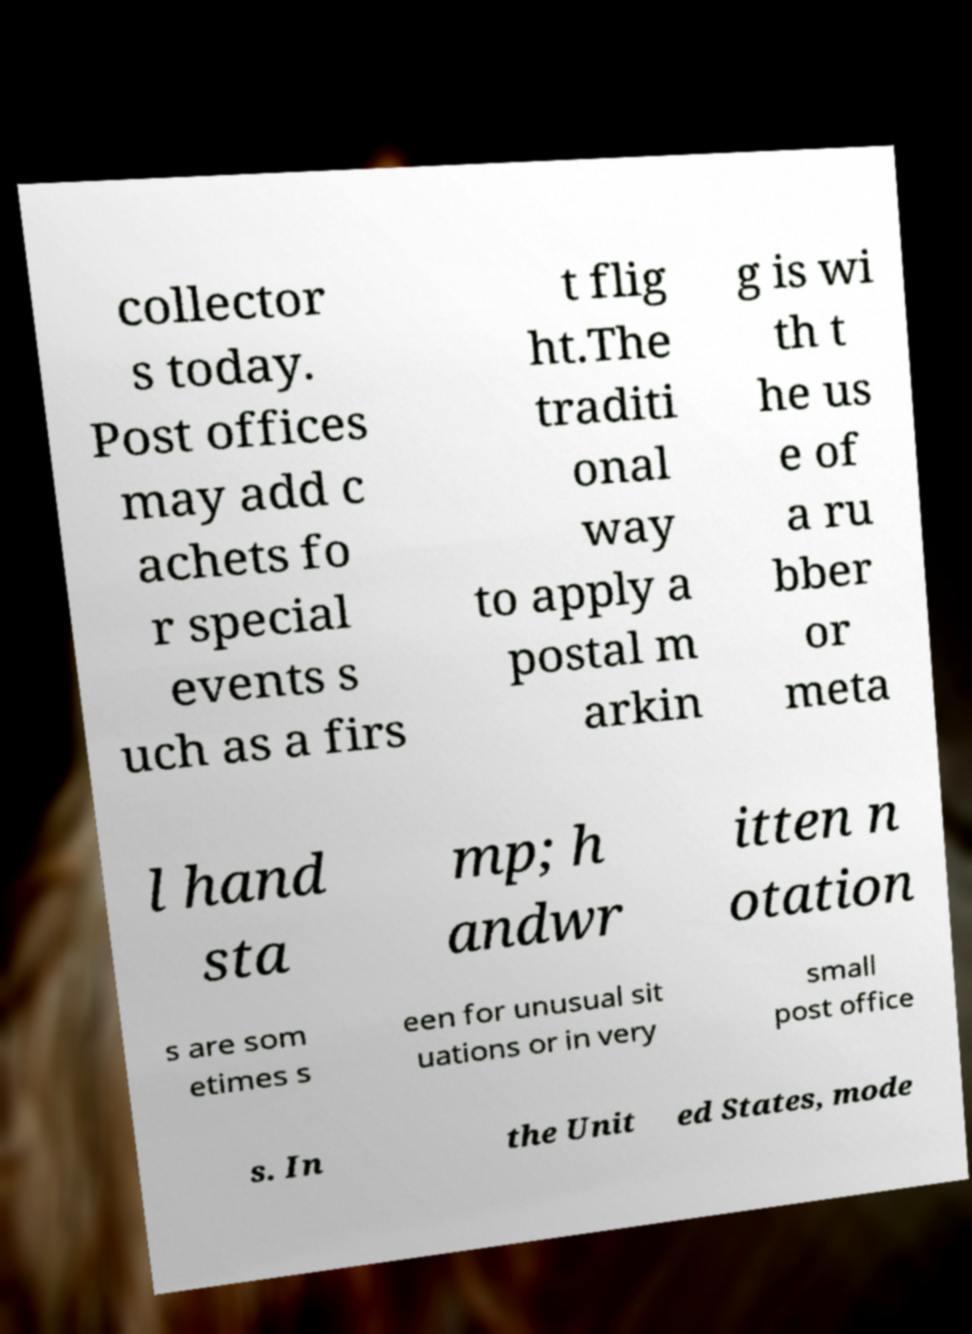Could you assist in decoding the text presented in this image and type it out clearly? collector s today. Post offices may add c achets fo r special events s uch as a firs t flig ht.The traditi onal way to apply a postal m arkin g is wi th t he us e of a ru bber or meta l hand sta mp; h andwr itten n otation s are som etimes s een for unusual sit uations or in very small post office s. In the Unit ed States, mode 